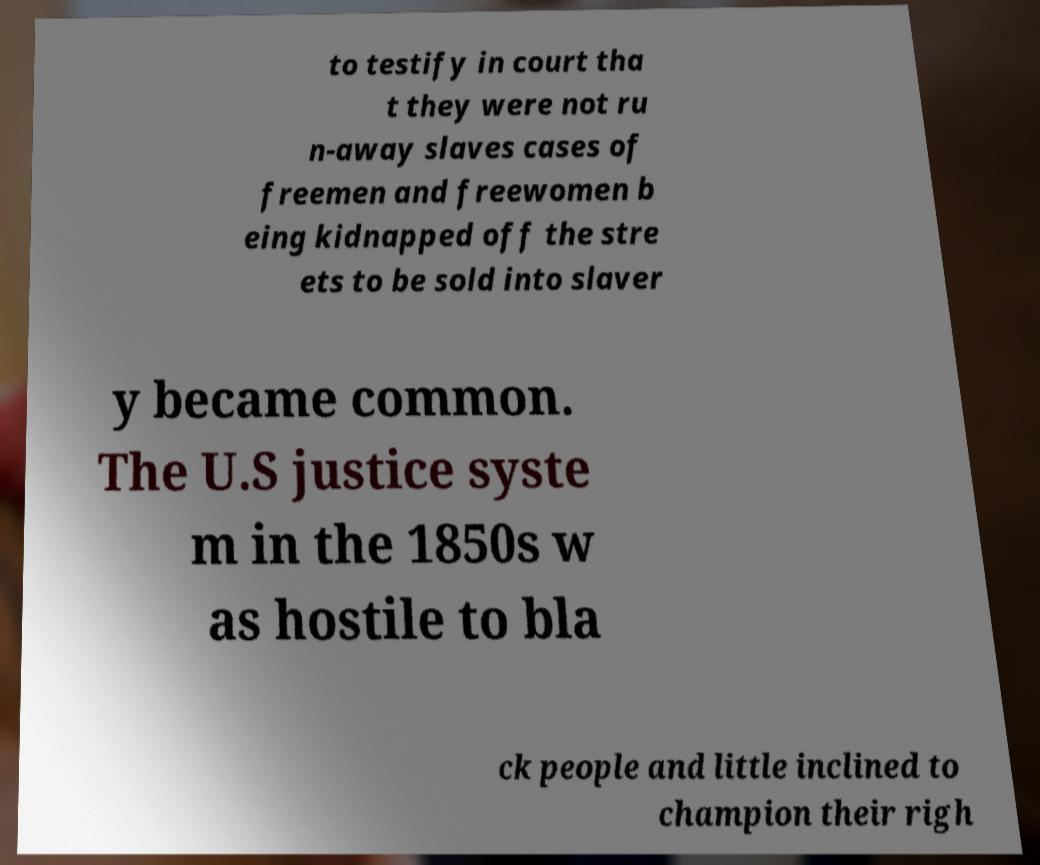Could you assist in decoding the text presented in this image and type it out clearly? to testify in court tha t they were not ru n-away slaves cases of freemen and freewomen b eing kidnapped off the stre ets to be sold into slaver y became common. The U.S justice syste m in the 1850s w as hostile to bla ck people and little inclined to champion their righ 